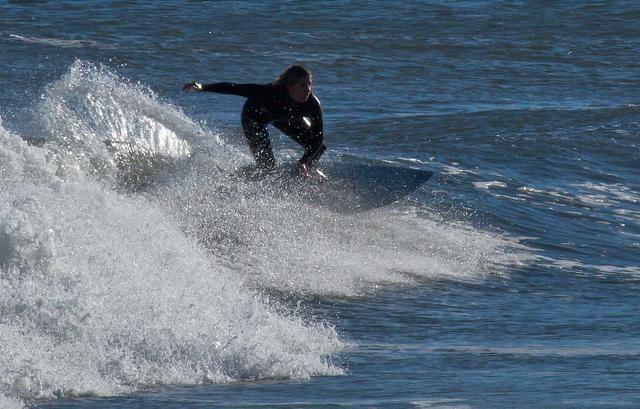How many surfboards can you see?
Give a very brief answer. 1. How many dogs are in this picture?
Give a very brief answer. 0. 